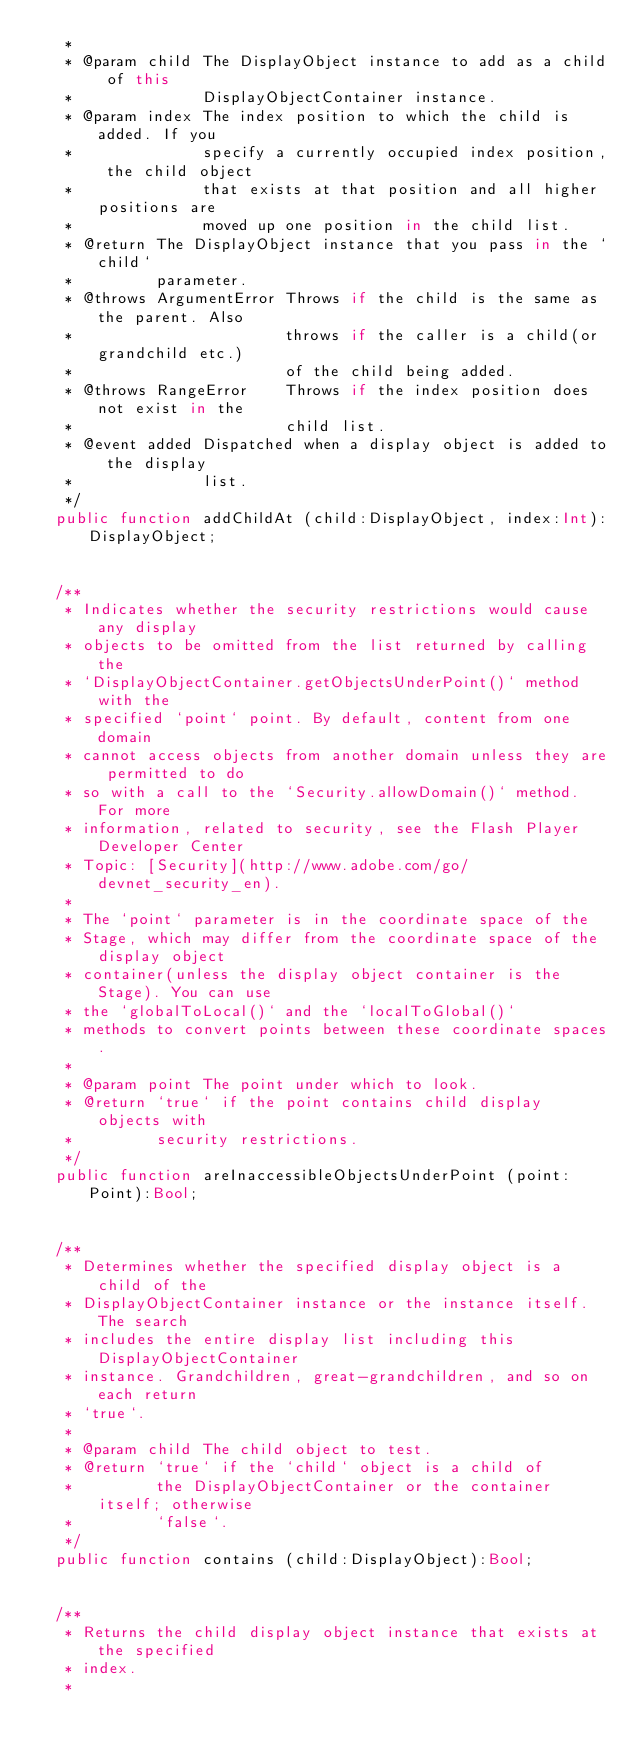<code> <loc_0><loc_0><loc_500><loc_500><_Haxe_>	 * 
	 * @param child The DisplayObject instance to add as a child of this
	 *              DisplayObjectContainer instance.
	 * @param index The index position to which the child is added. If you
	 *              specify a currently occupied index position, the child object
	 *              that exists at that position and all higher positions are
	 *              moved up one position in the child list.
	 * @return The DisplayObject instance that you pass in the `child`
	 *         parameter.
	 * @throws ArgumentError Throws if the child is the same as the parent. Also
	 *                       throws if the caller is a child(or grandchild etc.)
	 *                       of the child being added.
	 * @throws RangeError    Throws if the index position does not exist in the
	 *                       child list.
	 * @event added Dispatched when a display object is added to the display
	 *              list.
	 */
	public function addChildAt (child:DisplayObject, index:Int):DisplayObject;
	
	
	/**
	 * Indicates whether the security restrictions would cause any display
	 * objects to be omitted from the list returned by calling the
	 * `DisplayObjectContainer.getObjectsUnderPoint()` method with the
	 * specified `point` point. By default, content from one domain
	 * cannot access objects from another domain unless they are permitted to do
	 * so with a call to the `Security.allowDomain()` method. For more
	 * information, related to security, see the Flash Player Developer Center
	 * Topic: [Security](http://www.adobe.com/go/devnet_security_en).
	 *
	 * The `point` parameter is in the coordinate space of the
	 * Stage, which may differ from the coordinate space of the display object
	 * container(unless the display object container is the Stage). You can use
	 * the `globalToLocal()` and the `localToGlobal()`
	 * methods to convert points between these coordinate spaces.
	 * 
	 * @param point The point under which to look.
	 * @return `true` if the point contains child display objects with
	 *         security restrictions.
	 */
	public function areInaccessibleObjectsUnderPoint (point:Point):Bool;
	
	
	/**
	 * Determines whether the specified display object is a child of the
	 * DisplayObjectContainer instance or the instance itself. The search
	 * includes the entire display list including this DisplayObjectContainer
	 * instance. Grandchildren, great-grandchildren, and so on each return
	 * `true`.
	 * 
	 * @param child The child object to test.
	 * @return `true` if the `child` object is a child of
	 *         the DisplayObjectContainer or the container itself; otherwise
	 *         `false`.
	 */
	public function contains (child:DisplayObject):Bool;
	
	
	/**
	 * Returns the child display object instance that exists at the specified
	 * index.
	 * </code> 